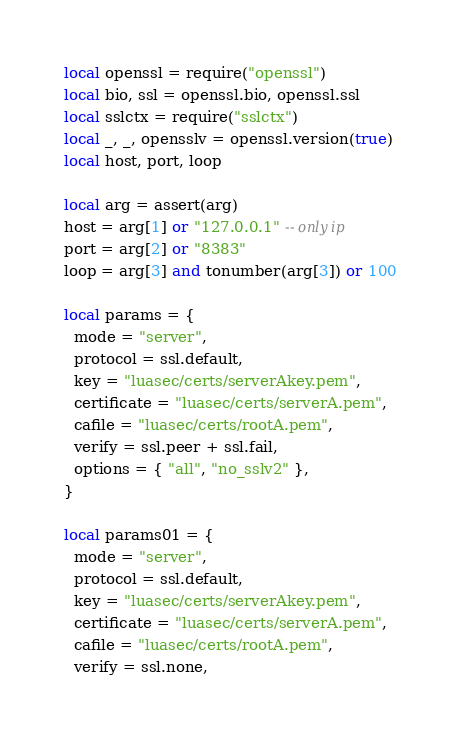Convert code to text. <code><loc_0><loc_0><loc_500><loc_500><_Lua_>local openssl = require("openssl")
local bio, ssl = openssl.bio, openssl.ssl
local sslctx = require("sslctx")
local _, _, opensslv = openssl.version(true)
local host, port, loop

local arg = assert(arg)
host = arg[1] or "127.0.0.1" -- only ip
port = arg[2] or "8383"
loop = arg[3] and tonumber(arg[3]) or 100

local params = {
  mode = "server",
  protocol = ssl.default,
  key = "luasec/certs/serverAkey.pem",
  certificate = "luasec/certs/serverA.pem",
  cafile = "luasec/certs/rootA.pem",
  verify = ssl.peer + ssl.fail,
  options = { "all", "no_sslv2" },
}

local params01 = {
  mode = "server",
  protocol = ssl.default,
  key = "luasec/certs/serverAkey.pem",
  certificate = "luasec/certs/serverA.pem",
  cafile = "luasec/certs/rootA.pem",
  verify = ssl.none,</code> 